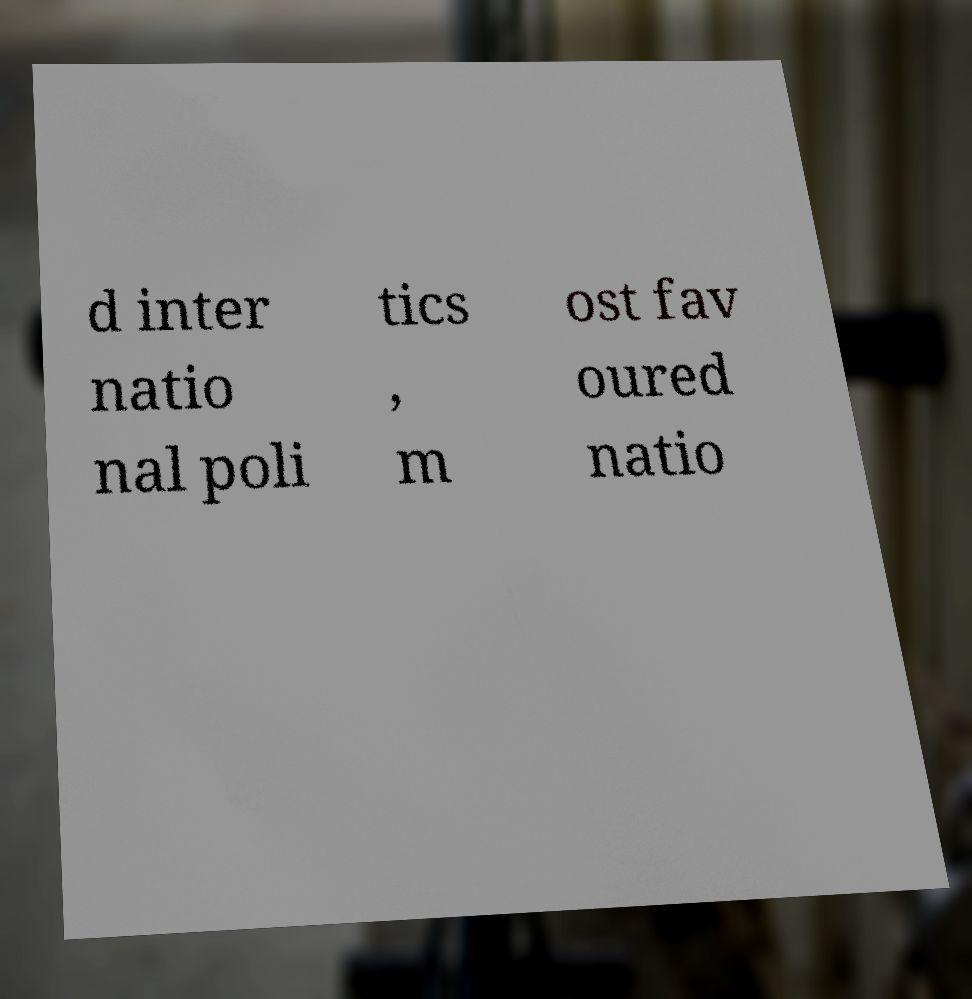Please read and relay the text visible in this image. What does it say? d inter natio nal poli tics , m ost fav oured natio 